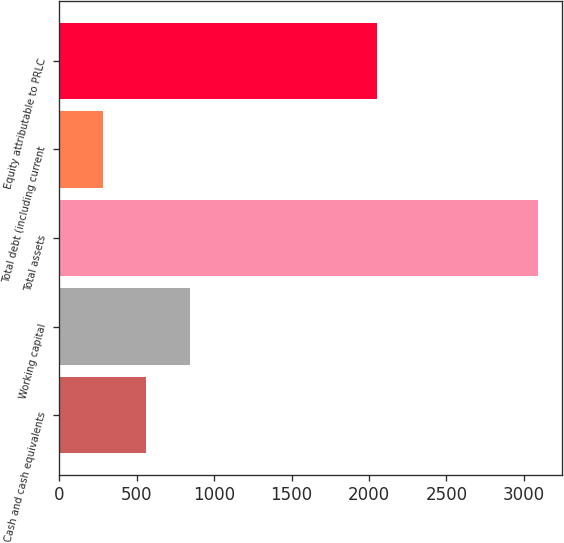Convert chart. <chart><loc_0><loc_0><loc_500><loc_500><bar_chart><fcel>Cash and cash equivalents<fcel>Working capital<fcel>Total assets<fcel>Total debt (including current<fcel>Equity attributable to PRLC<nl><fcel>561.23<fcel>842.06<fcel>3088.7<fcel>280.4<fcel>2049.6<nl></chart> 